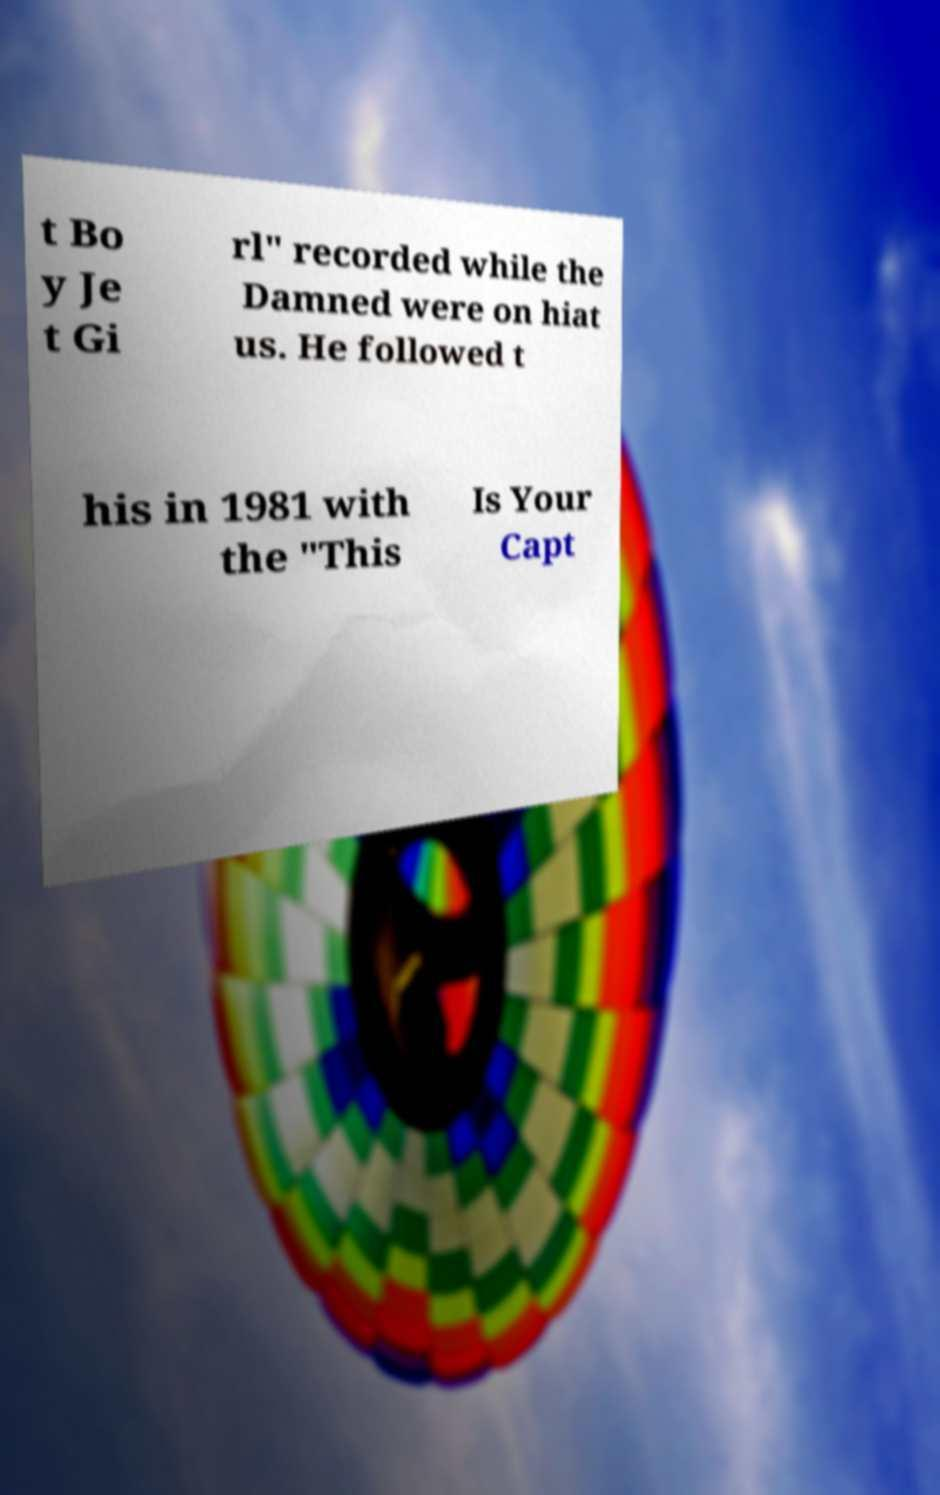There's text embedded in this image that I need extracted. Can you transcribe it verbatim? t Bo y Je t Gi rl" recorded while the Damned were on hiat us. He followed t his in 1981 with the "This Is Your Capt 